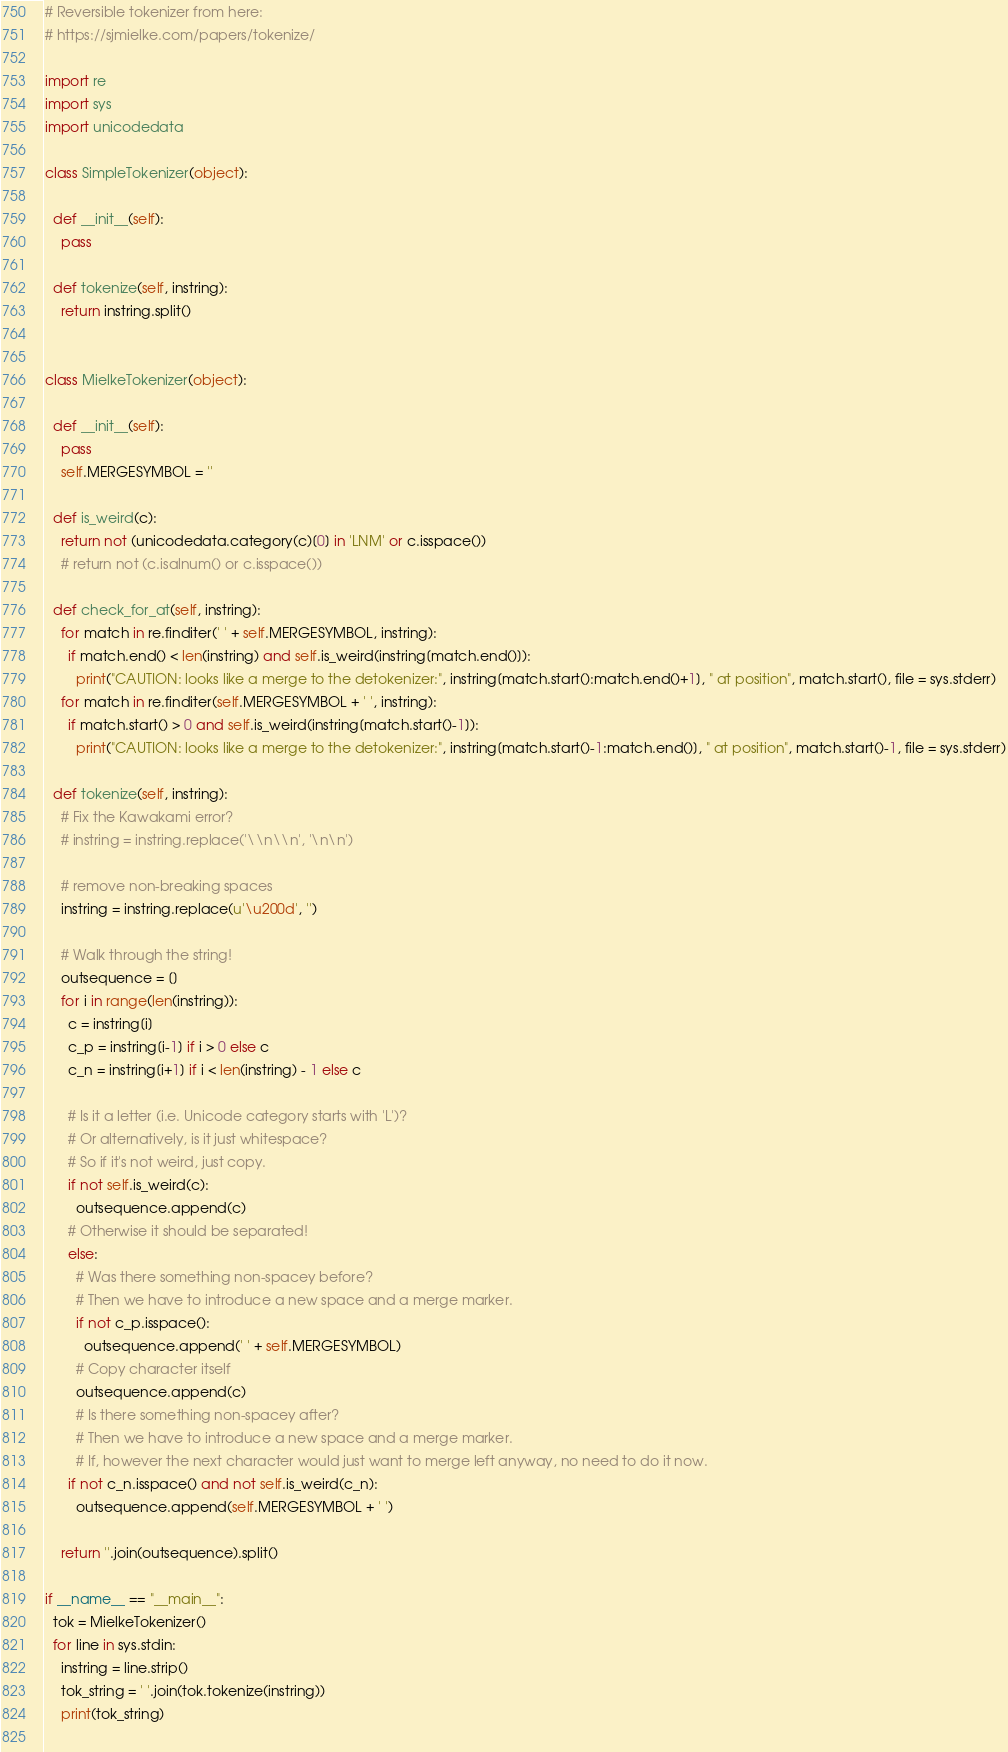Convert code to text. <code><loc_0><loc_0><loc_500><loc_500><_Python_># Reversible tokenizer from here:
# https://sjmielke.com/papers/tokenize/

import re
import sys
import unicodedata

class SimpleTokenizer(object):

  def __init__(self):
    pass

  def tokenize(self, instring):
    return instring.split()


class MielkeTokenizer(object):

  def __init__(self):
    pass
    self.MERGESYMBOL = ''

  def is_weird(c):
    return not (unicodedata.category(c)[0] in 'LNM' or c.isspace())
    # return not (c.isalnum() or c.isspace())

  def check_for_at(self, instring):
    for match in re.finditer(' ' + self.MERGESYMBOL, instring):
      if match.end() < len(instring) and self.is_weird(instring[match.end()]):
        print("CAUTION: looks like a merge to the detokenizer:", instring[match.start():match.end()+1], " at position", match.start(), file = sys.stderr)
    for match in re.finditer(self.MERGESYMBOL + ' ', instring):
      if match.start() > 0 and self.is_weird(instring[match.start()-1]):
        print("CAUTION: looks like a merge to the detokenizer:", instring[match.start()-1:match.end()], " at position", match.start()-1, file = sys.stderr)

  def tokenize(self, instring):
    # Fix the Kawakami error?
    # instring = instring.replace('\\n\\n', '\n\n')

    # remove non-breaking spaces
    instring = instring.replace(u'\u200d', '')

    # Walk through the string!
    outsequence = []
    for i in range(len(instring)):
      c = instring[i]
      c_p = instring[i-1] if i > 0 else c
      c_n = instring[i+1] if i < len(instring) - 1 else c

      # Is it a letter (i.e. Unicode category starts with 'L')?
      # Or alternatively, is it just whitespace?
      # So if it's not weird, just copy.
      if not self.is_weird(c):
        outsequence.append(c)
      # Otherwise it should be separated!
      else:
        # Was there something non-spacey before?
        # Then we have to introduce a new space and a merge marker.
        if not c_p.isspace():
          outsequence.append(' ' + self.MERGESYMBOL)
        # Copy character itself
        outsequence.append(c)
        # Is there something non-spacey after?
        # Then we have to introduce a new space and a merge marker.
        # If, however the next character would just want to merge left anyway, no need to do it now.
      if not c_n.isspace() and not self.is_weird(c_n):
        outsequence.append(self.MERGESYMBOL + ' ')

    return ''.join(outsequence).split()

if __name__ == "__main__":
  tok = MielkeTokenizer()
  for line in sys.stdin:
    instring = line.strip()
    tok_string = ' '.join(tok.tokenize(instring))
    print(tok_string)
 

</code> 